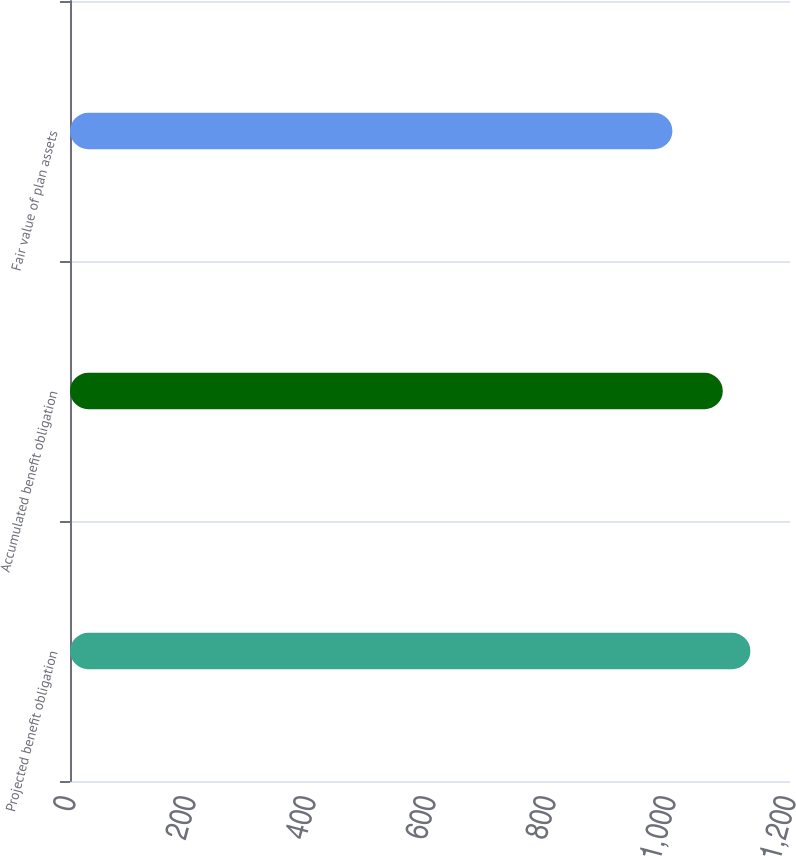<chart> <loc_0><loc_0><loc_500><loc_500><bar_chart><fcel>Projected benefit obligation<fcel>Accumulated benefit obligation<fcel>Fair value of plan assets<nl><fcel>1134<fcel>1088<fcel>1004<nl></chart> 